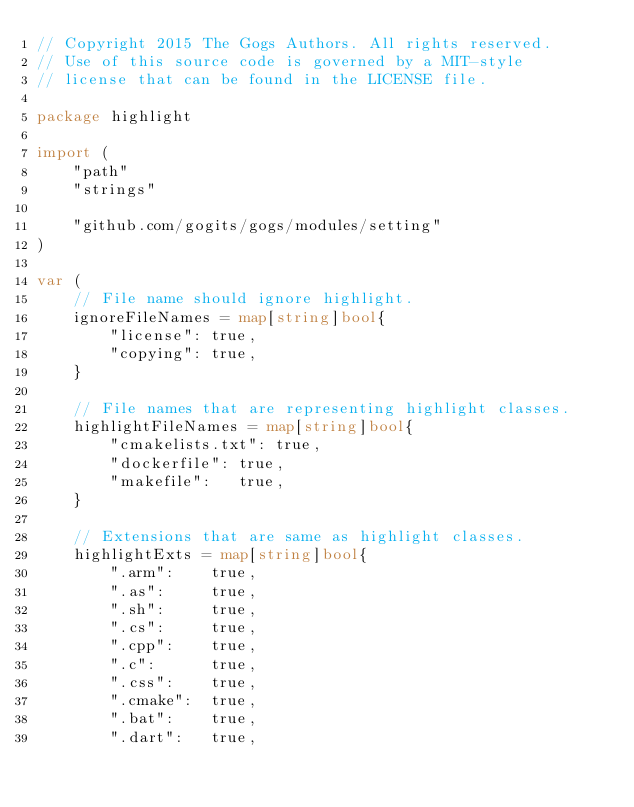Convert code to text. <code><loc_0><loc_0><loc_500><loc_500><_Go_>// Copyright 2015 The Gogs Authors. All rights reserved.
// Use of this source code is governed by a MIT-style
// license that can be found in the LICENSE file.

package highlight

import (
	"path"
	"strings"

	"github.com/gogits/gogs/modules/setting"
)

var (
	// File name should ignore highlight.
	ignoreFileNames = map[string]bool{
		"license": true,
		"copying": true,
	}

	// File names that are representing highlight classes.
	highlightFileNames = map[string]bool{
		"cmakelists.txt": true,
		"dockerfile": true,
		"makefile":   true,
	}

	// Extensions that are same as highlight classes.
	highlightExts = map[string]bool{
		".arm":    true,
		".as":     true,
		".sh":     true,
		".cs":     true,
		".cpp":    true,
		".c":      true,
		".css":    true,
		".cmake":  true,
		".bat":    true,
		".dart":   true,</code> 